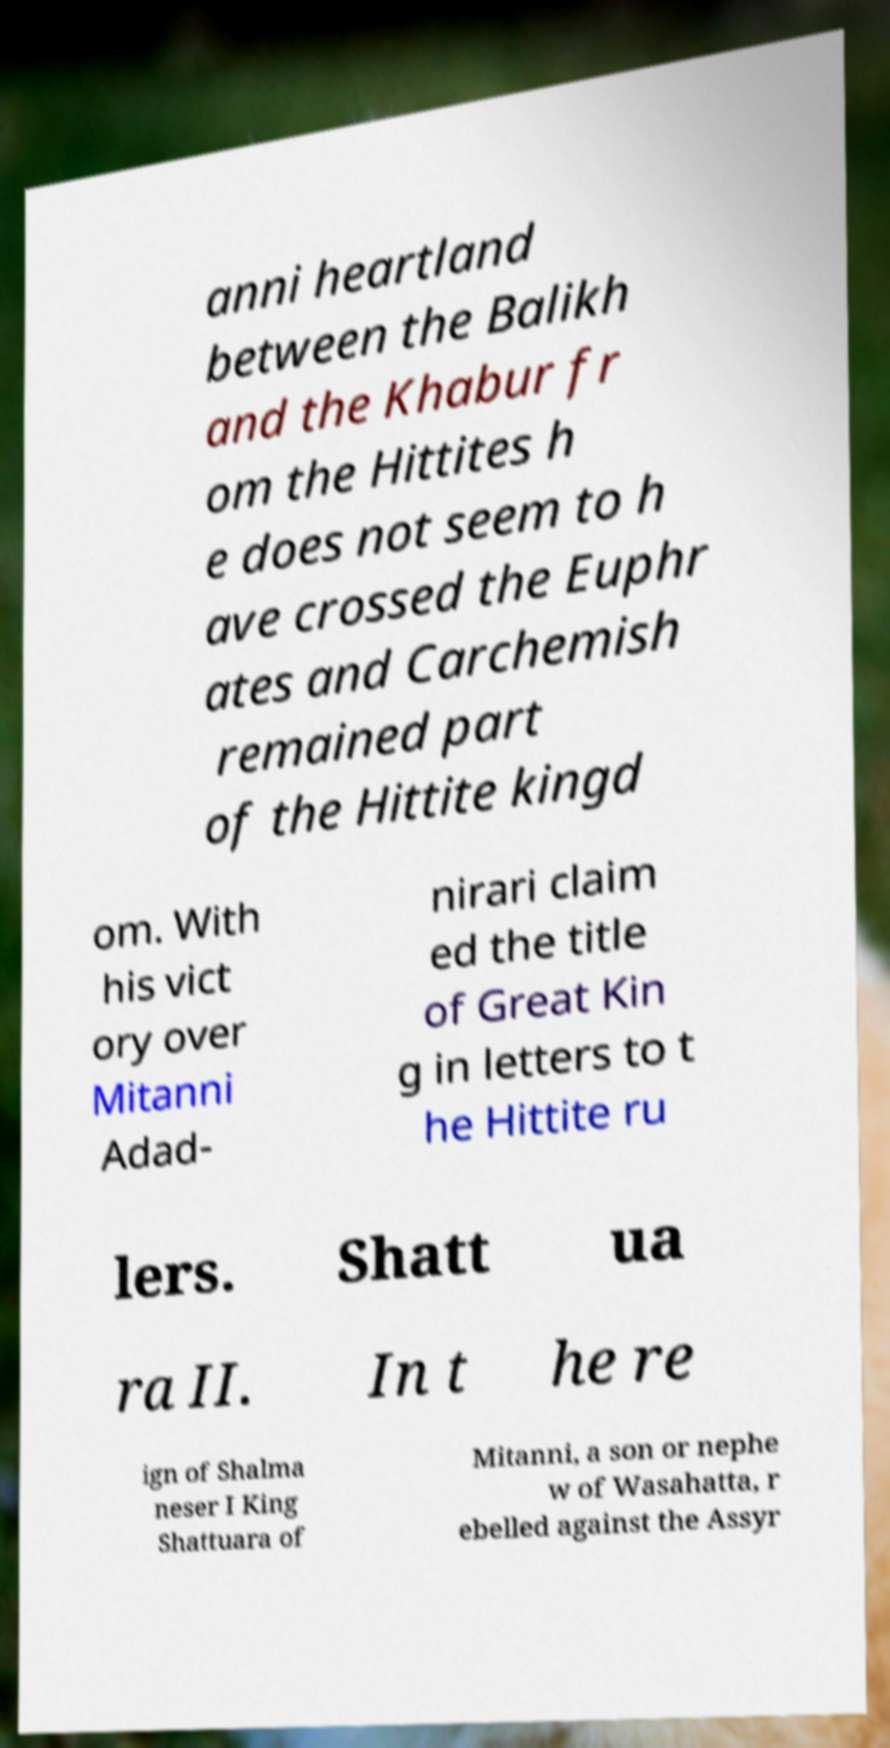For documentation purposes, I need the text within this image transcribed. Could you provide that? anni heartland between the Balikh and the Khabur fr om the Hittites h e does not seem to h ave crossed the Euphr ates and Carchemish remained part of the Hittite kingd om. With his vict ory over Mitanni Adad- nirari claim ed the title of Great Kin g in letters to t he Hittite ru lers. Shatt ua ra II. In t he re ign of Shalma neser I King Shattuara of Mitanni, a son or nephe w of Wasahatta, r ebelled against the Assyr 